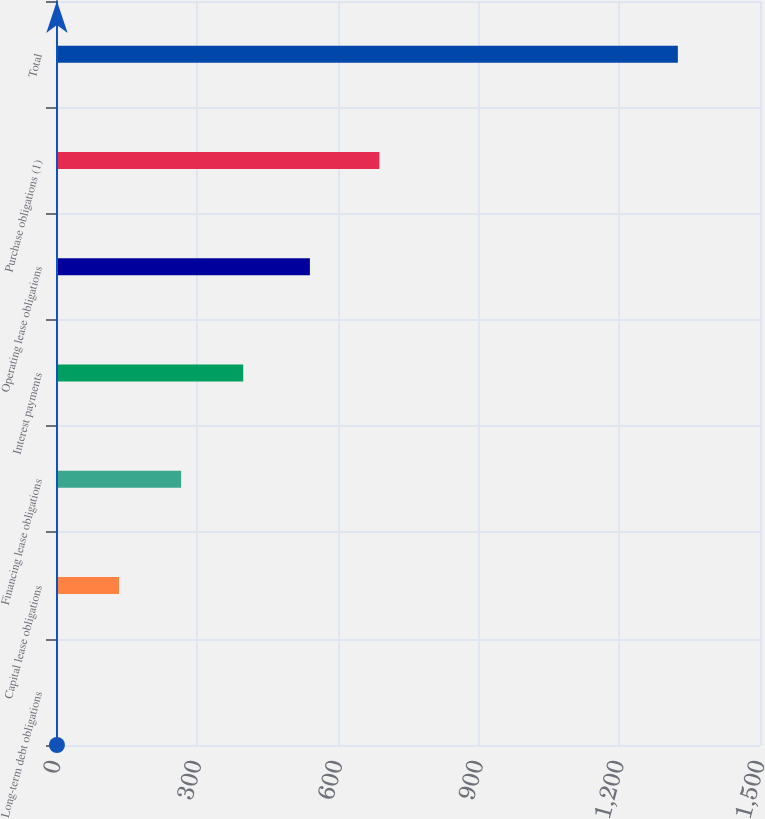<chart> <loc_0><loc_0><loc_500><loc_500><bar_chart><fcel>Long-term debt obligations<fcel>Capital lease obligations<fcel>Financing lease obligations<fcel>Interest payments<fcel>Operating lease obligations<fcel>Purchase obligations (1)<fcel>Total<nl><fcel>2<fcel>134.3<fcel>266.6<fcel>398.9<fcel>541<fcel>689<fcel>1325<nl></chart> 